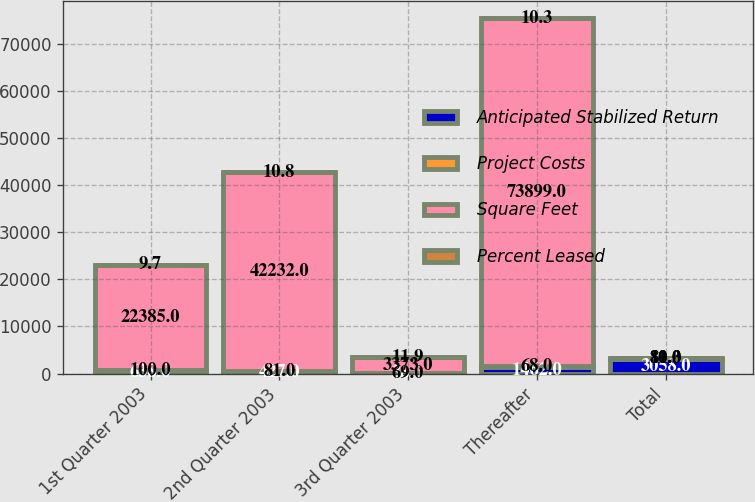Convert chart. <chart><loc_0><loc_0><loc_500><loc_500><stacked_bar_chart><ecel><fcel>1st Quarter 2003<fcel>2nd Quarter 2003<fcel>3rd Quarter 2003<fcel>Thereafter<fcel>Total<nl><fcel>Anticipated Stabilized Return<fcel>638<fcel>427<fcel>38<fcel>1462<fcel>3058<nl><fcel>Project Costs<fcel>100<fcel>81<fcel>69<fcel>68<fcel>80<nl><fcel>Square Feet<fcel>22385<fcel>42232<fcel>3373<fcel>73899<fcel>81<nl><fcel>Percent Leased<fcel>9.7<fcel>10.8<fcel>11.9<fcel>10.3<fcel>10.3<nl></chart> 